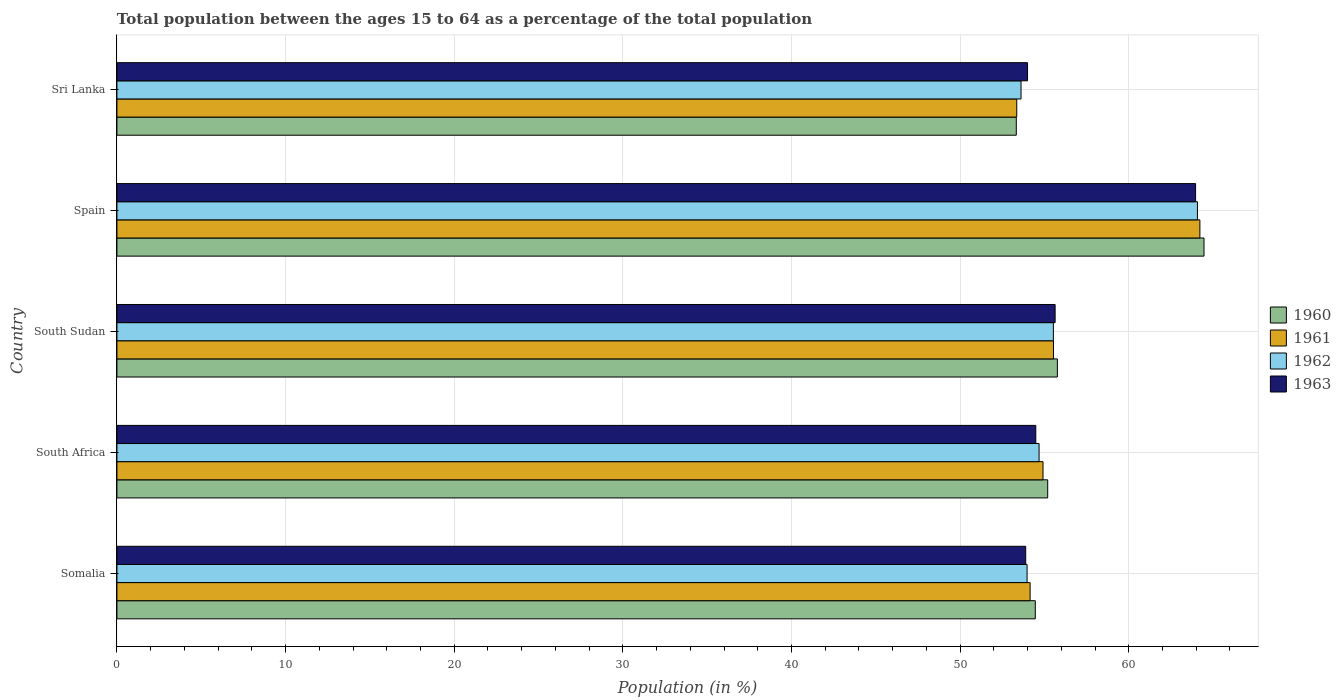How many different coloured bars are there?
Keep it short and to the point. 4. How many bars are there on the 3rd tick from the bottom?
Offer a very short reply. 4. What is the label of the 5th group of bars from the top?
Provide a short and direct response. Somalia. What is the percentage of the population ages 15 to 64 in 1962 in Sri Lanka?
Your answer should be compact. 53.61. Across all countries, what is the maximum percentage of the population ages 15 to 64 in 1961?
Offer a terse response. 64.22. Across all countries, what is the minimum percentage of the population ages 15 to 64 in 1960?
Your response must be concise. 53.33. In which country was the percentage of the population ages 15 to 64 in 1961 maximum?
Your answer should be very brief. Spain. In which country was the percentage of the population ages 15 to 64 in 1961 minimum?
Provide a succinct answer. Sri Lanka. What is the total percentage of the population ages 15 to 64 in 1960 in the graph?
Provide a short and direct response. 283.2. What is the difference between the percentage of the population ages 15 to 64 in 1962 in Somalia and that in South Africa?
Make the answer very short. -0.71. What is the difference between the percentage of the population ages 15 to 64 in 1963 in South Sudan and the percentage of the population ages 15 to 64 in 1962 in Spain?
Your answer should be very brief. -8.44. What is the average percentage of the population ages 15 to 64 in 1961 per country?
Offer a very short reply. 56.43. What is the difference between the percentage of the population ages 15 to 64 in 1963 and percentage of the population ages 15 to 64 in 1960 in South Sudan?
Your answer should be very brief. -0.13. In how many countries, is the percentage of the population ages 15 to 64 in 1960 greater than 42 ?
Your answer should be very brief. 5. What is the ratio of the percentage of the population ages 15 to 64 in 1963 in South Africa to that in Spain?
Offer a very short reply. 0.85. Is the percentage of the population ages 15 to 64 in 1961 in Somalia less than that in Sri Lanka?
Provide a succinct answer. No. What is the difference between the highest and the second highest percentage of the population ages 15 to 64 in 1961?
Offer a very short reply. 8.68. What is the difference between the highest and the lowest percentage of the population ages 15 to 64 in 1960?
Provide a short and direct response. 11.13. Is it the case that in every country, the sum of the percentage of the population ages 15 to 64 in 1961 and percentage of the population ages 15 to 64 in 1962 is greater than the sum of percentage of the population ages 15 to 64 in 1960 and percentage of the population ages 15 to 64 in 1963?
Offer a terse response. No. What does the 2nd bar from the bottom in Spain represents?
Ensure brevity in your answer.  1961. Is it the case that in every country, the sum of the percentage of the population ages 15 to 64 in 1961 and percentage of the population ages 15 to 64 in 1960 is greater than the percentage of the population ages 15 to 64 in 1962?
Give a very brief answer. Yes. Are all the bars in the graph horizontal?
Provide a short and direct response. Yes. How many countries are there in the graph?
Make the answer very short. 5. Where does the legend appear in the graph?
Keep it short and to the point. Center right. What is the title of the graph?
Give a very brief answer. Total population between the ages 15 to 64 as a percentage of the total population. Does "1997" appear as one of the legend labels in the graph?
Your answer should be compact. No. What is the label or title of the X-axis?
Provide a short and direct response. Population (in %). What is the label or title of the Y-axis?
Ensure brevity in your answer.  Country. What is the Population (in %) in 1960 in Somalia?
Provide a short and direct response. 54.46. What is the Population (in %) in 1961 in Somalia?
Keep it short and to the point. 54.15. What is the Population (in %) in 1962 in Somalia?
Your response must be concise. 53.97. What is the Population (in %) in 1963 in Somalia?
Your answer should be very brief. 53.89. What is the Population (in %) of 1960 in South Africa?
Your answer should be compact. 55.19. What is the Population (in %) in 1961 in South Africa?
Provide a short and direct response. 54.91. What is the Population (in %) in 1962 in South Africa?
Your response must be concise. 54.68. What is the Population (in %) of 1963 in South Africa?
Your response must be concise. 54.49. What is the Population (in %) in 1960 in South Sudan?
Make the answer very short. 55.77. What is the Population (in %) in 1961 in South Sudan?
Provide a succinct answer. 55.54. What is the Population (in %) of 1962 in South Sudan?
Provide a succinct answer. 55.53. What is the Population (in %) in 1963 in South Sudan?
Provide a succinct answer. 55.63. What is the Population (in %) of 1960 in Spain?
Your answer should be very brief. 64.46. What is the Population (in %) in 1961 in Spain?
Your answer should be very brief. 64.22. What is the Population (in %) of 1962 in Spain?
Ensure brevity in your answer.  64.07. What is the Population (in %) of 1963 in Spain?
Your answer should be very brief. 63.96. What is the Population (in %) of 1960 in Sri Lanka?
Offer a very short reply. 53.33. What is the Population (in %) of 1961 in Sri Lanka?
Your answer should be compact. 53.36. What is the Population (in %) of 1962 in Sri Lanka?
Offer a very short reply. 53.61. What is the Population (in %) in 1963 in Sri Lanka?
Provide a succinct answer. 54. Across all countries, what is the maximum Population (in %) in 1960?
Offer a very short reply. 64.46. Across all countries, what is the maximum Population (in %) in 1961?
Offer a very short reply. 64.22. Across all countries, what is the maximum Population (in %) of 1962?
Offer a terse response. 64.07. Across all countries, what is the maximum Population (in %) of 1963?
Your answer should be compact. 63.96. Across all countries, what is the minimum Population (in %) of 1960?
Make the answer very short. 53.33. Across all countries, what is the minimum Population (in %) of 1961?
Your answer should be very brief. 53.36. Across all countries, what is the minimum Population (in %) in 1962?
Your response must be concise. 53.61. Across all countries, what is the minimum Population (in %) of 1963?
Offer a very short reply. 53.89. What is the total Population (in %) in 1960 in the graph?
Ensure brevity in your answer.  283.2. What is the total Population (in %) in 1961 in the graph?
Ensure brevity in your answer.  282.17. What is the total Population (in %) in 1962 in the graph?
Offer a terse response. 281.86. What is the total Population (in %) in 1963 in the graph?
Make the answer very short. 281.97. What is the difference between the Population (in %) in 1960 in Somalia and that in South Africa?
Your answer should be very brief. -0.74. What is the difference between the Population (in %) of 1961 in Somalia and that in South Africa?
Offer a terse response. -0.76. What is the difference between the Population (in %) in 1962 in Somalia and that in South Africa?
Provide a succinct answer. -0.71. What is the difference between the Population (in %) of 1963 in Somalia and that in South Africa?
Your response must be concise. -0.6. What is the difference between the Population (in %) of 1960 in Somalia and that in South Sudan?
Provide a short and direct response. -1.31. What is the difference between the Population (in %) in 1961 in Somalia and that in South Sudan?
Offer a very short reply. -1.39. What is the difference between the Population (in %) of 1962 in Somalia and that in South Sudan?
Your answer should be compact. -1.56. What is the difference between the Population (in %) of 1963 in Somalia and that in South Sudan?
Your response must be concise. -1.74. What is the difference between the Population (in %) of 1960 in Somalia and that in Spain?
Your answer should be very brief. -10. What is the difference between the Population (in %) of 1961 in Somalia and that in Spain?
Make the answer very short. -10.07. What is the difference between the Population (in %) in 1962 in Somalia and that in Spain?
Your answer should be compact. -10.1. What is the difference between the Population (in %) in 1963 in Somalia and that in Spain?
Your answer should be compact. -10.07. What is the difference between the Population (in %) in 1960 in Somalia and that in Sri Lanka?
Provide a succinct answer. 1.13. What is the difference between the Population (in %) in 1961 in Somalia and that in Sri Lanka?
Ensure brevity in your answer.  0.79. What is the difference between the Population (in %) of 1962 in Somalia and that in Sri Lanka?
Make the answer very short. 0.36. What is the difference between the Population (in %) of 1963 in Somalia and that in Sri Lanka?
Provide a short and direct response. -0.11. What is the difference between the Population (in %) in 1960 in South Africa and that in South Sudan?
Your answer should be compact. -0.57. What is the difference between the Population (in %) of 1961 in South Africa and that in South Sudan?
Keep it short and to the point. -0.62. What is the difference between the Population (in %) of 1962 in South Africa and that in South Sudan?
Keep it short and to the point. -0.85. What is the difference between the Population (in %) of 1963 in South Africa and that in South Sudan?
Make the answer very short. -1.15. What is the difference between the Population (in %) in 1960 in South Africa and that in Spain?
Your answer should be compact. -9.27. What is the difference between the Population (in %) in 1961 in South Africa and that in Spain?
Provide a succinct answer. -9.3. What is the difference between the Population (in %) of 1962 in South Africa and that in Spain?
Your answer should be compact. -9.39. What is the difference between the Population (in %) of 1963 in South Africa and that in Spain?
Your answer should be compact. -9.48. What is the difference between the Population (in %) of 1960 in South Africa and that in Sri Lanka?
Keep it short and to the point. 1.86. What is the difference between the Population (in %) in 1961 in South Africa and that in Sri Lanka?
Offer a terse response. 1.56. What is the difference between the Population (in %) of 1962 in South Africa and that in Sri Lanka?
Your answer should be very brief. 1.07. What is the difference between the Population (in %) in 1963 in South Africa and that in Sri Lanka?
Ensure brevity in your answer.  0.49. What is the difference between the Population (in %) of 1960 in South Sudan and that in Spain?
Make the answer very short. -8.7. What is the difference between the Population (in %) in 1961 in South Sudan and that in Spain?
Ensure brevity in your answer.  -8.68. What is the difference between the Population (in %) of 1962 in South Sudan and that in Spain?
Your answer should be compact. -8.54. What is the difference between the Population (in %) in 1963 in South Sudan and that in Spain?
Offer a very short reply. -8.33. What is the difference between the Population (in %) in 1960 in South Sudan and that in Sri Lanka?
Provide a succinct answer. 2.44. What is the difference between the Population (in %) of 1961 in South Sudan and that in Sri Lanka?
Make the answer very short. 2.18. What is the difference between the Population (in %) in 1962 in South Sudan and that in Sri Lanka?
Provide a short and direct response. 1.92. What is the difference between the Population (in %) of 1963 in South Sudan and that in Sri Lanka?
Your response must be concise. 1.64. What is the difference between the Population (in %) of 1960 in Spain and that in Sri Lanka?
Offer a terse response. 11.13. What is the difference between the Population (in %) in 1961 in Spain and that in Sri Lanka?
Offer a very short reply. 10.86. What is the difference between the Population (in %) in 1962 in Spain and that in Sri Lanka?
Provide a succinct answer. 10.46. What is the difference between the Population (in %) in 1963 in Spain and that in Sri Lanka?
Your answer should be compact. 9.97. What is the difference between the Population (in %) in 1960 in Somalia and the Population (in %) in 1961 in South Africa?
Give a very brief answer. -0.46. What is the difference between the Population (in %) of 1960 in Somalia and the Population (in %) of 1962 in South Africa?
Your response must be concise. -0.22. What is the difference between the Population (in %) of 1960 in Somalia and the Population (in %) of 1963 in South Africa?
Your answer should be very brief. -0.03. What is the difference between the Population (in %) in 1961 in Somalia and the Population (in %) in 1962 in South Africa?
Provide a succinct answer. -0.53. What is the difference between the Population (in %) of 1961 in Somalia and the Population (in %) of 1963 in South Africa?
Provide a succinct answer. -0.34. What is the difference between the Population (in %) in 1962 in Somalia and the Population (in %) in 1963 in South Africa?
Your answer should be very brief. -0.52. What is the difference between the Population (in %) in 1960 in Somalia and the Population (in %) in 1961 in South Sudan?
Ensure brevity in your answer.  -1.08. What is the difference between the Population (in %) of 1960 in Somalia and the Population (in %) of 1962 in South Sudan?
Give a very brief answer. -1.07. What is the difference between the Population (in %) in 1960 in Somalia and the Population (in %) in 1963 in South Sudan?
Your answer should be very brief. -1.18. What is the difference between the Population (in %) of 1961 in Somalia and the Population (in %) of 1962 in South Sudan?
Provide a short and direct response. -1.38. What is the difference between the Population (in %) of 1961 in Somalia and the Population (in %) of 1963 in South Sudan?
Offer a very short reply. -1.48. What is the difference between the Population (in %) of 1962 in Somalia and the Population (in %) of 1963 in South Sudan?
Offer a very short reply. -1.66. What is the difference between the Population (in %) in 1960 in Somalia and the Population (in %) in 1961 in Spain?
Offer a terse response. -9.76. What is the difference between the Population (in %) of 1960 in Somalia and the Population (in %) of 1962 in Spain?
Your response must be concise. -9.62. What is the difference between the Population (in %) of 1960 in Somalia and the Population (in %) of 1963 in Spain?
Offer a terse response. -9.51. What is the difference between the Population (in %) in 1961 in Somalia and the Population (in %) in 1962 in Spain?
Provide a succinct answer. -9.92. What is the difference between the Population (in %) in 1961 in Somalia and the Population (in %) in 1963 in Spain?
Provide a short and direct response. -9.81. What is the difference between the Population (in %) in 1962 in Somalia and the Population (in %) in 1963 in Spain?
Your answer should be very brief. -9.99. What is the difference between the Population (in %) of 1960 in Somalia and the Population (in %) of 1961 in Sri Lanka?
Offer a very short reply. 1.1. What is the difference between the Population (in %) of 1960 in Somalia and the Population (in %) of 1962 in Sri Lanka?
Your answer should be very brief. 0.85. What is the difference between the Population (in %) in 1960 in Somalia and the Population (in %) in 1963 in Sri Lanka?
Give a very brief answer. 0.46. What is the difference between the Population (in %) in 1961 in Somalia and the Population (in %) in 1962 in Sri Lanka?
Keep it short and to the point. 0.54. What is the difference between the Population (in %) of 1961 in Somalia and the Population (in %) of 1963 in Sri Lanka?
Ensure brevity in your answer.  0.15. What is the difference between the Population (in %) of 1962 in Somalia and the Population (in %) of 1963 in Sri Lanka?
Give a very brief answer. -0.03. What is the difference between the Population (in %) in 1960 in South Africa and the Population (in %) in 1961 in South Sudan?
Give a very brief answer. -0.34. What is the difference between the Population (in %) in 1960 in South Africa and the Population (in %) in 1962 in South Sudan?
Give a very brief answer. -0.34. What is the difference between the Population (in %) of 1960 in South Africa and the Population (in %) of 1963 in South Sudan?
Offer a very short reply. -0.44. What is the difference between the Population (in %) in 1961 in South Africa and the Population (in %) in 1962 in South Sudan?
Keep it short and to the point. -0.61. What is the difference between the Population (in %) of 1961 in South Africa and the Population (in %) of 1963 in South Sudan?
Make the answer very short. -0.72. What is the difference between the Population (in %) in 1962 in South Africa and the Population (in %) in 1963 in South Sudan?
Provide a succinct answer. -0.95. What is the difference between the Population (in %) in 1960 in South Africa and the Population (in %) in 1961 in Spain?
Keep it short and to the point. -9.03. What is the difference between the Population (in %) of 1960 in South Africa and the Population (in %) of 1962 in Spain?
Your answer should be very brief. -8.88. What is the difference between the Population (in %) of 1960 in South Africa and the Population (in %) of 1963 in Spain?
Your response must be concise. -8.77. What is the difference between the Population (in %) in 1961 in South Africa and the Population (in %) in 1962 in Spain?
Offer a terse response. -9.16. What is the difference between the Population (in %) of 1961 in South Africa and the Population (in %) of 1963 in Spain?
Your response must be concise. -9.05. What is the difference between the Population (in %) of 1962 in South Africa and the Population (in %) of 1963 in Spain?
Keep it short and to the point. -9.28. What is the difference between the Population (in %) in 1960 in South Africa and the Population (in %) in 1961 in Sri Lanka?
Ensure brevity in your answer.  1.84. What is the difference between the Population (in %) in 1960 in South Africa and the Population (in %) in 1962 in Sri Lanka?
Offer a very short reply. 1.58. What is the difference between the Population (in %) of 1960 in South Africa and the Population (in %) of 1963 in Sri Lanka?
Give a very brief answer. 1.19. What is the difference between the Population (in %) in 1961 in South Africa and the Population (in %) in 1962 in Sri Lanka?
Ensure brevity in your answer.  1.3. What is the difference between the Population (in %) of 1961 in South Africa and the Population (in %) of 1963 in Sri Lanka?
Make the answer very short. 0.92. What is the difference between the Population (in %) in 1962 in South Africa and the Population (in %) in 1963 in Sri Lanka?
Your answer should be very brief. 0.68. What is the difference between the Population (in %) of 1960 in South Sudan and the Population (in %) of 1961 in Spain?
Ensure brevity in your answer.  -8.45. What is the difference between the Population (in %) of 1960 in South Sudan and the Population (in %) of 1962 in Spain?
Your answer should be very brief. -8.31. What is the difference between the Population (in %) of 1960 in South Sudan and the Population (in %) of 1963 in Spain?
Your response must be concise. -8.2. What is the difference between the Population (in %) in 1961 in South Sudan and the Population (in %) in 1962 in Spain?
Give a very brief answer. -8.54. What is the difference between the Population (in %) of 1961 in South Sudan and the Population (in %) of 1963 in Spain?
Give a very brief answer. -8.43. What is the difference between the Population (in %) of 1962 in South Sudan and the Population (in %) of 1963 in Spain?
Offer a very short reply. -8.43. What is the difference between the Population (in %) of 1960 in South Sudan and the Population (in %) of 1961 in Sri Lanka?
Your answer should be very brief. 2.41. What is the difference between the Population (in %) of 1960 in South Sudan and the Population (in %) of 1962 in Sri Lanka?
Keep it short and to the point. 2.15. What is the difference between the Population (in %) of 1960 in South Sudan and the Population (in %) of 1963 in Sri Lanka?
Your answer should be very brief. 1.77. What is the difference between the Population (in %) of 1961 in South Sudan and the Population (in %) of 1962 in Sri Lanka?
Your response must be concise. 1.92. What is the difference between the Population (in %) in 1961 in South Sudan and the Population (in %) in 1963 in Sri Lanka?
Make the answer very short. 1.54. What is the difference between the Population (in %) of 1962 in South Sudan and the Population (in %) of 1963 in Sri Lanka?
Your answer should be very brief. 1.53. What is the difference between the Population (in %) in 1960 in Spain and the Population (in %) in 1961 in Sri Lanka?
Provide a short and direct response. 11.1. What is the difference between the Population (in %) of 1960 in Spain and the Population (in %) of 1962 in Sri Lanka?
Your answer should be compact. 10.85. What is the difference between the Population (in %) of 1960 in Spain and the Population (in %) of 1963 in Sri Lanka?
Offer a very short reply. 10.46. What is the difference between the Population (in %) in 1961 in Spain and the Population (in %) in 1962 in Sri Lanka?
Your answer should be compact. 10.61. What is the difference between the Population (in %) of 1961 in Spain and the Population (in %) of 1963 in Sri Lanka?
Offer a terse response. 10.22. What is the difference between the Population (in %) in 1962 in Spain and the Population (in %) in 1963 in Sri Lanka?
Offer a terse response. 10.07. What is the average Population (in %) of 1960 per country?
Keep it short and to the point. 56.64. What is the average Population (in %) of 1961 per country?
Provide a succinct answer. 56.43. What is the average Population (in %) in 1962 per country?
Your answer should be very brief. 56.37. What is the average Population (in %) of 1963 per country?
Your answer should be compact. 56.39. What is the difference between the Population (in %) in 1960 and Population (in %) in 1961 in Somalia?
Provide a succinct answer. 0.31. What is the difference between the Population (in %) of 1960 and Population (in %) of 1962 in Somalia?
Ensure brevity in your answer.  0.49. What is the difference between the Population (in %) of 1960 and Population (in %) of 1963 in Somalia?
Give a very brief answer. 0.57. What is the difference between the Population (in %) in 1961 and Population (in %) in 1962 in Somalia?
Offer a terse response. 0.18. What is the difference between the Population (in %) of 1961 and Population (in %) of 1963 in Somalia?
Offer a terse response. 0.26. What is the difference between the Population (in %) of 1962 and Population (in %) of 1963 in Somalia?
Give a very brief answer. 0.08. What is the difference between the Population (in %) of 1960 and Population (in %) of 1961 in South Africa?
Your response must be concise. 0.28. What is the difference between the Population (in %) of 1960 and Population (in %) of 1962 in South Africa?
Provide a succinct answer. 0.51. What is the difference between the Population (in %) in 1960 and Population (in %) in 1963 in South Africa?
Your answer should be compact. 0.71. What is the difference between the Population (in %) in 1961 and Population (in %) in 1962 in South Africa?
Ensure brevity in your answer.  0.23. What is the difference between the Population (in %) of 1961 and Population (in %) of 1963 in South Africa?
Your response must be concise. 0.43. What is the difference between the Population (in %) of 1962 and Population (in %) of 1963 in South Africa?
Keep it short and to the point. 0.19. What is the difference between the Population (in %) in 1960 and Population (in %) in 1961 in South Sudan?
Provide a succinct answer. 0.23. What is the difference between the Population (in %) of 1960 and Population (in %) of 1962 in South Sudan?
Offer a terse response. 0.24. What is the difference between the Population (in %) in 1960 and Population (in %) in 1963 in South Sudan?
Ensure brevity in your answer.  0.13. What is the difference between the Population (in %) in 1961 and Population (in %) in 1962 in South Sudan?
Give a very brief answer. 0.01. What is the difference between the Population (in %) of 1961 and Population (in %) of 1963 in South Sudan?
Provide a succinct answer. -0.1. What is the difference between the Population (in %) in 1962 and Population (in %) in 1963 in South Sudan?
Offer a terse response. -0.1. What is the difference between the Population (in %) in 1960 and Population (in %) in 1961 in Spain?
Provide a succinct answer. 0.24. What is the difference between the Population (in %) in 1960 and Population (in %) in 1962 in Spain?
Provide a short and direct response. 0.39. What is the difference between the Population (in %) in 1960 and Population (in %) in 1963 in Spain?
Offer a terse response. 0.5. What is the difference between the Population (in %) of 1961 and Population (in %) of 1962 in Spain?
Offer a very short reply. 0.15. What is the difference between the Population (in %) in 1961 and Population (in %) in 1963 in Spain?
Ensure brevity in your answer.  0.26. What is the difference between the Population (in %) of 1962 and Population (in %) of 1963 in Spain?
Give a very brief answer. 0.11. What is the difference between the Population (in %) of 1960 and Population (in %) of 1961 in Sri Lanka?
Offer a very short reply. -0.03. What is the difference between the Population (in %) in 1960 and Population (in %) in 1962 in Sri Lanka?
Offer a terse response. -0.28. What is the difference between the Population (in %) of 1960 and Population (in %) of 1963 in Sri Lanka?
Provide a short and direct response. -0.67. What is the difference between the Population (in %) in 1961 and Population (in %) in 1962 in Sri Lanka?
Provide a succinct answer. -0.25. What is the difference between the Population (in %) of 1961 and Population (in %) of 1963 in Sri Lanka?
Keep it short and to the point. -0.64. What is the difference between the Population (in %) in 1962 and Population (in %) in 1963 in Sri Lanka?
Provide a succinct answer. -0.39. What is the ratio of the Population (in %) of 1960 in Somalia to that in South Africa?
Provide a short and direct response. 0.99. What is the ratio of the Population (in %) of 1961 in Somalia to that in South Africa?
Offer a terse response. 0.99. What is the ratio of the Population (in %) in 1962 in Somalia to that in South Africa?
Give a very brief answer. 0.99. What is the ratio of the Population (in %) in 1960 in Somalia to that in South Sudan?
Provide a succinct answer. 0.98. What is the ratio of the Population (in %) of 1961 in Somalia to that in South Sudan?
Your answer should be compact. 0.97. What is the ratio of the Population (in %) in 1962 in Somalia to that in South Sudan?
Ensure brevity in your answer.  0.97. What is the ratio of the Population (in %) of 1963 in Somalia to that in South Sudan?
Your response must be concise. 0.97. What is the ratio of the Population (in %) in 1960 in Somalia to that in Spain?
Provide a short and direct response. 0.84. What is the ratio of the Population (in %) in 1961 in Somalia to that in Spain?
Ensure brevity in your answer.  0.84. What is the ratio of the Population (in %) of 1962 in Somalia to that in Spain?
Offer a very short reply. 0.84. What is the ratio of the Population (in %) of 1963 in Somalia to that in Spain?
Your answer should be very brief. 0.84. What is the ratio of the Population (in %) in 1960 in Somalia to that in Sri Lanka?
Make the answer very short. 1.02. What is the ratio of the Population (in %) in 1961 in Somalia to that in Sri Lanka?
Your response must be concise. 1.01. What is the ratio of the Population (in %) of 1963 in Somalia to that in Sri Lanka?
Offer a very short reply. 1. What is the ratio of the Population (in %) of 1960 in South Africa to that in South Sudan?
Offer a very short reply. 0.99. What is the ratio of the Population (in %) of 1962 in South Africa to that in South Sudan?
Your response must be concise. 0.98. What is the ratio of the Population (in %) of 1963 in South Africa to that in South Sudan?
Give a very brief answer. 0.98. What is the ratio of the Population (in %) in 1960 in South Africa to that in Spain?
Give a very brief answer. 0.86. What is the ratio of the Population (in %) in 1961 in South Africa to that in Spain?
Keep it short and to the point. 0.86. What is the ratio of the Population (in %) in 1962 in South Africa to that in Spain?
Provide a short and direct response. 0.85. What is the ratio of the Population (in %) of 1963 in South Africa to that in Spain?
Your answer should be compact. 0.85. What is the ratio of the Population (in %) of 1960 in South Africa to that in Sri Lanka?
Provide a short and direct response. 1.03. What is the ratio of the Population (in %) of 1961 in South Africa to that in Sri Lanka?
Your response must be concise. 1.03. What is the ratio of the Population (in %) of 1962 in South Africa to that in Sri Lanka?
Keep it short and to the point. 1.02. What is the ratio of the Population (in %) in 1963 in South Africa to that in Sri Lanka?
Give a very brief answer. 1.01. What is the ratio of the Population (in %) of 1960 in South Sudan to that in Spain?
Offer a very short reply. 0.87. What is the ratio of the Population (in %) of 1961 in South Sudan to that in Spain?
Keep it short and to the point. 0.86. What is the ratio of the Population (in %) of 1962 in South Sudan to that in Spain?
Keep it short and to the point. 0.87. What is the ratio of the Population (in %) of 1963 in South Sudan to that in Spain?
Make the answer very short. 0.87. What is the ratio of the Population (in %) of 1960 in South Sudan to that in Sri Lanka?
Provide a short and direct response. 1.05. What is the ratio of the Population (in %) in 1961 in South Sudan to that in Sri Lanka?
Keep it short and to the point. 1.04. What is the ratio of the Population (in %) of 1962 in South Sudan to that in Sri Lanka?
Give a very brief answer. 1.04. What is the ratio of the Population (in %) of 1963 in South Sudan to that in Sri Lanka?
Keep it short and to the point. 1.03. What is the ratio of the Population (in %) in 1960 in Spain to that in Sri Lanka?
Offer a very short reply. 1.21. What is the ratio of the Population (in %) in 1961 in Spain to that in Sri Lanka?
Keep it short and to the point. 1.2. What is the ratio of the Population (in %) in 1962 in Spain to that in Sri Lanka?
Give a very brief answer. 1.2. What is the ratio of the Population (in %) of 1963 in Spain to that in Sri Lanka?
Provide a short and direct response. 1.18. What is the difference between the highest and the second highest Population (in %) in 1960?
Your response must be concise. 8.7. What is the difference between the highest and the second highest Population (in %) in 1961?
Offer a very short reply. 8.68. What is the difference between the highest and the second highest Population (in %) of 1962?
Your answer should be compact. 8.54. What is the difference between the highest and the second highest Population (in %) in 1963?
Offer a very short reply. 8.33. What is the difference between the highest and the lowest Population (in %) in 1960?
Provide a short and direct response. 11.13. What is the difference between the highest and the lowest Population (in %) of 1961?
Ensure brevity in your answer.  10.86. What is the difference between the highest and the lowest Population (in %) of 1962?
Your response must be concise. 10.46. What is the difference between the highest and the lowest Population (in %) in 1963?
Provide a short and direct response. 10.07. 